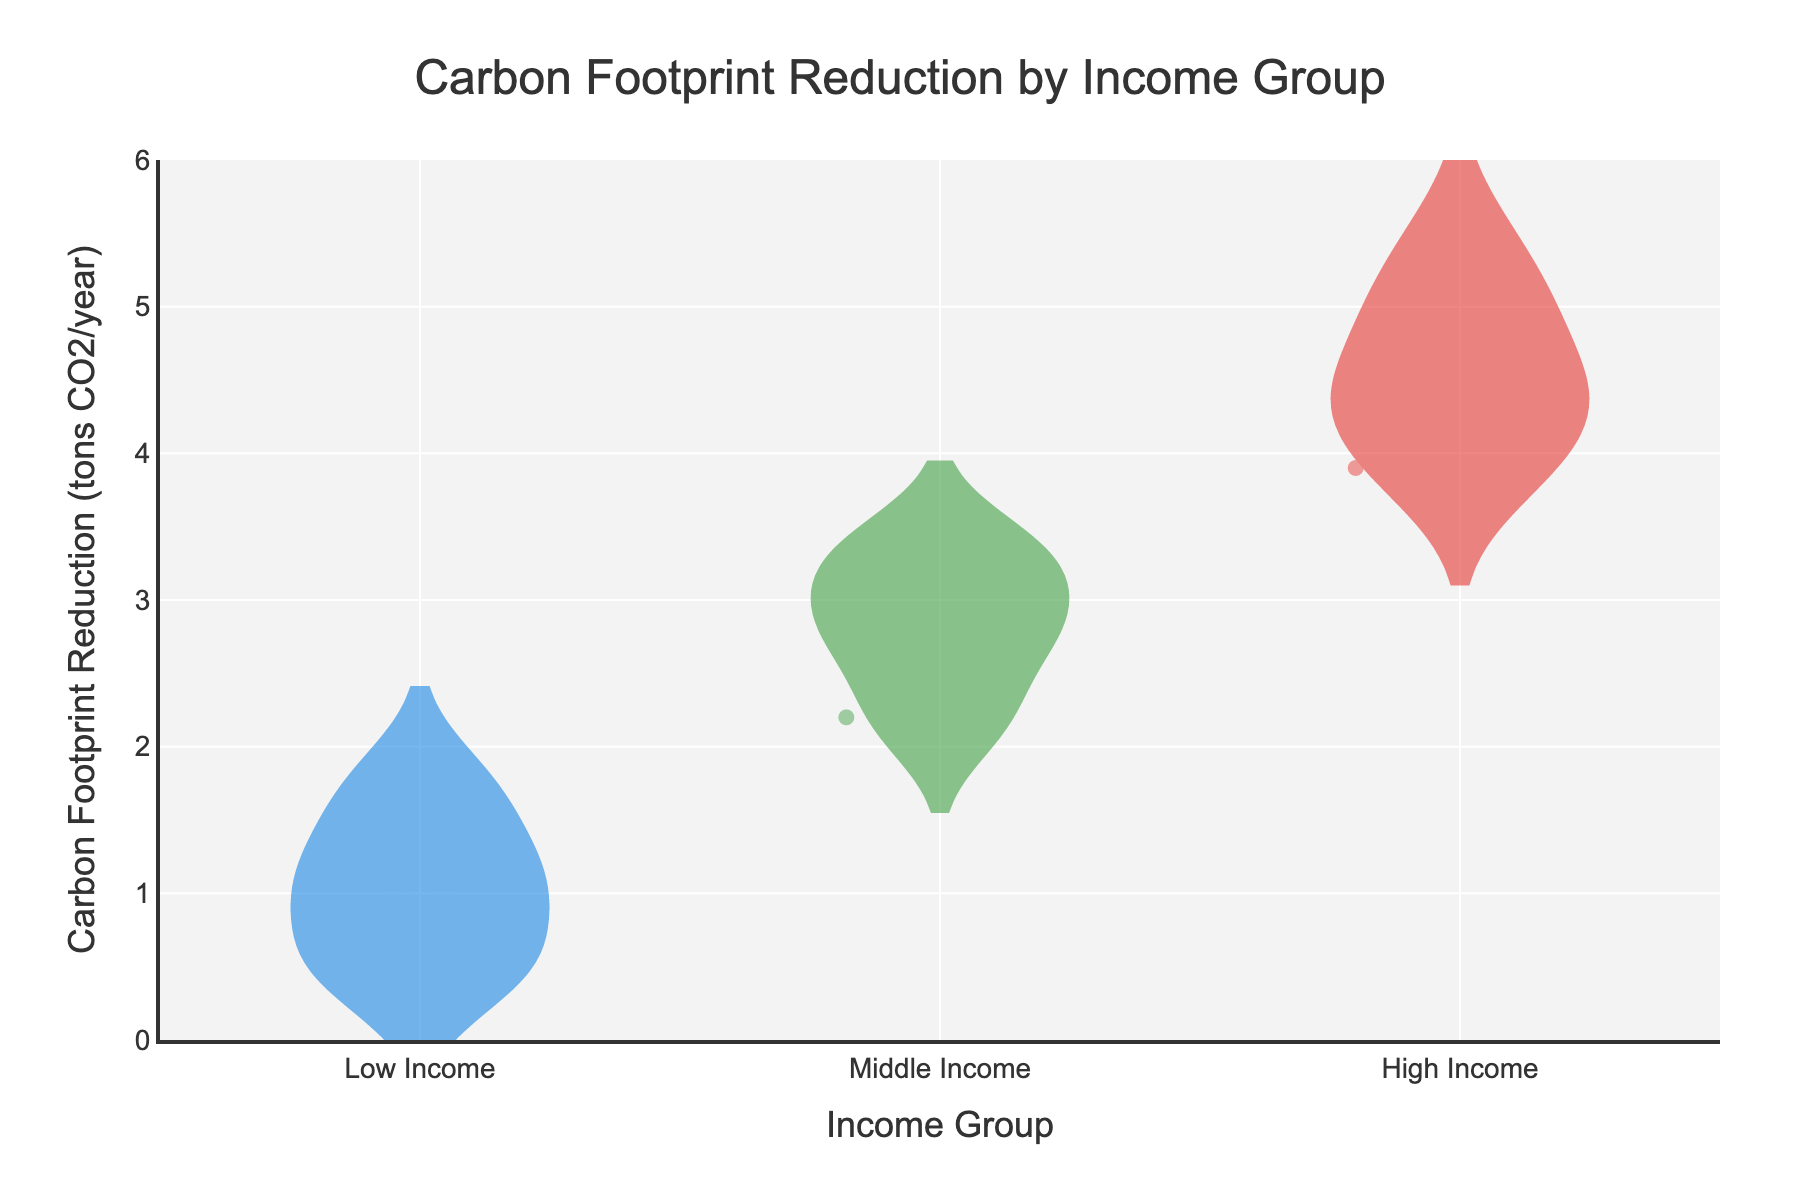What's the title of the figure? The title of the figure is located at the top and usually summarizes what the graph is about. In this case, the title is "Carbon Footprint Reduction by Income Group".
Answer: Carbon Footprint Reduction by Income Group What is the y-axis title in the figure? The y-axis title is provided to indicate what the y-axis values represent. In this case, the y-axis title is "Carbon Footprint Reduction (tons CO2/year)".
Answer: Carbon Footprint Reduction (tons CO2/year) Which income group shows the highest average carbon footprint reduction? By examining the mean lines shown within the violin plots, the High Income group's mean line is at a higher value compared to the others.
Answer: High Income How many panel installation points are plotted for the Low Income group? The jittered points within the violin plot represent individual data points. Counting the points within the Low Income section reveals 8 data points.
Answer: 8 Which income group demonstrates the widest spread of carbon footprint reductions? The spread (or width) of a violin plot can be assessed by looking at the width of the violin. The Middle Income group has the widest spread in terms of y-values.
Answer: Middle Income Compare the maximum carbon footprint reduction values between High Income and Middle Income groups. Which is greater? The maximum value is the highest point on the y-axis within each violin. For the High Income group, the highest reduction value exceeds that of the Middle Income group's highest point.
Answer: High Income Estimate the median carbon footprint reduction for the Low Income group. The median of a dataset in a violin plot is typically indicated by a line within the box. The median line for the Low Income group is around 1.1 tons CO2/year.
Answer: 1.1 tons CO2/year What is the interquartile range of carbon footprint reduction for the Middle Income group? The interquartile range is the difference between the third quartile and the first quartile, which can be identified between the top and bottom of the box sections in each violin plot. For Middle Income, it appears to be between 2.5 and 4 tons CO2/year.
Answer: 1.5 tons CO2/year What trend can be observed about carbon footprint reduction when comparing the Low, Middle, and High Income groups? Observing the mean lines and the spread of each violin plot, carbon footprint reduction increases with higher income levels. Both the median and mean values increase from Low Income to High Income.
Answer: Increasing trend from Low to High Income 